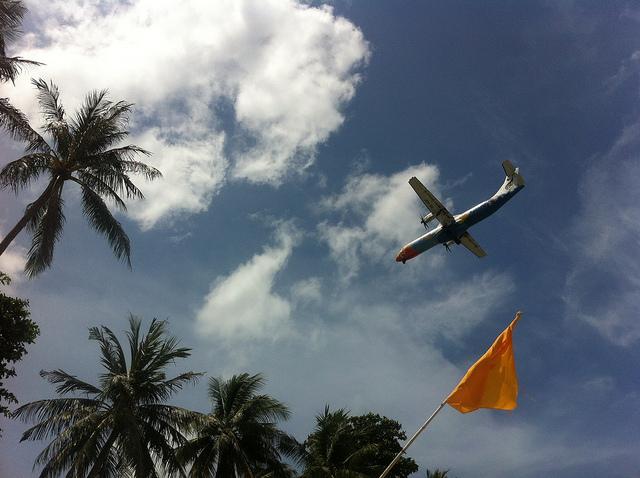How is the sky?
Keep it brief. Cloudy. What color is the flag?
Short answer required. Orange. What number of clouds are above the airplane?
Write a very short answer. 3. Is the plane at full altitude?
Keep it brief. No. 